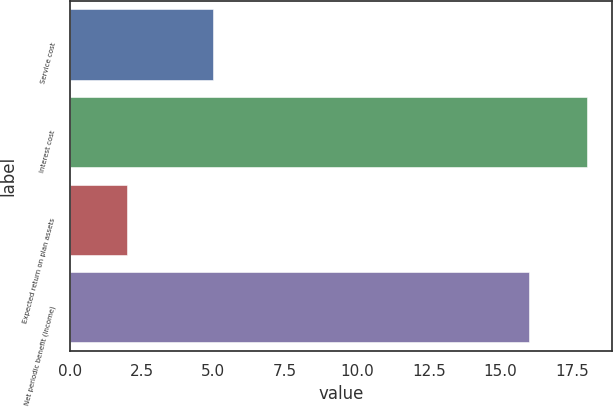Convert chart to OTSL. <chart><loc_0><loc_0><loc_500><loc_500><bar_chart><fcel>Service cost<fcel>Interest cost<fcel>Expected return on plan assets<fcel>Net periodic benefit (income)<nl><fcel>5<fcel>18<fcel>2<fcel>16<nl></chart> 